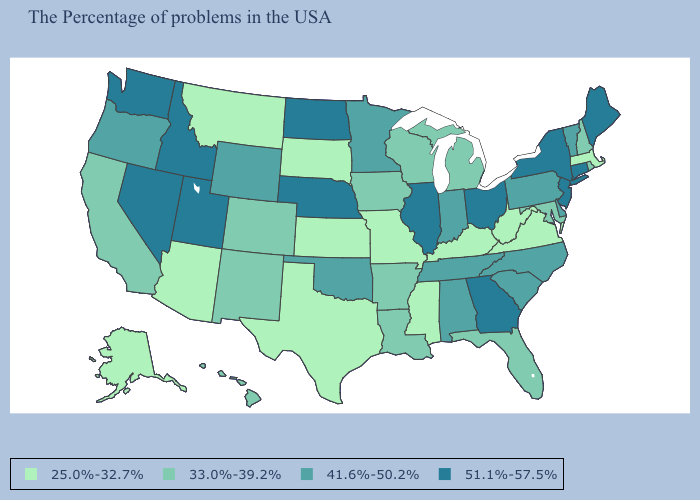Is the legend a continuous bar?
Quick response, please. No. Which states have the highest value in the USA?
Be succinct. Maine, Connecticut, New York, New Jersey, Ohio, Georgia, Illinois, Nebraska, North Dakota, Utah, Idaho, Nevada, Washington. Among the states that border Maryland , does Pennsylvania have the lowest value?
Answer briefly. No. Is the legend a continuous bar?
Keep it brief. No. Among the states that border Arkansas , which have the lowest value?
Short answer required. Mississippi, Missouri, Texas. What is the highest value in the South ?
Keep it brief. 51.1%-57.5%. What is the value of Connecticut?
Keep it brief. 51.1%-57.5%. Name the states that have a value in the range 51.1%-57.5%?
Short answer required. Maine, Connecticut, New York, New Jersey, Ohio, Georgia, Illinois, Nebraska, North Dakota, Utah, Idaho, Nevada, Washington. Does Virginia have a lower value than Kansas?
Short answer required. No. Name the states that have a value in the range 25.0%-32.7%?
Concise answer only. Massachusetts, Virginia, West Virginia, Kentucky, Mississippi, Missouri, Kansas, Texas, South Dakota, Montana, Arizona, Alaska. Does Mississippi have the highest value in the South?
Be succinct. No. What is the value of Texas?
Keep it brief. 25.0%-32.7%. Name the states that have a value in the range 33.0%-39.2%?
Answer briefly. Rhode Island, New Hampshire, Maryland, Florida, Michigan, Wisconsin, Louisiana, Arkansas, Iowa, Colorado, New Mexico, California, Hawaii. Name the states that have a value in the range 41.6%-50.2%?
Answer briefly. Vermont, Delaware, Pennsylvania, North Carolina, South Carolina, Indiana, Alabama, Tennessee, Minnesota, Oklahoma, Wyoming, Oregon. 